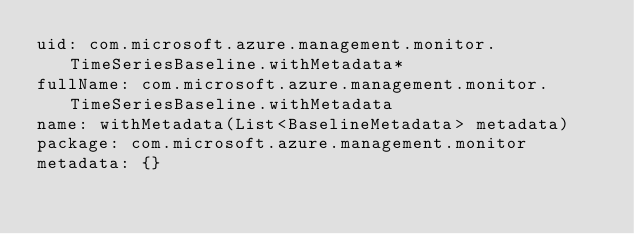<code> <loc_0><loc_0><loc_500><loc_500><_YAML_>uid: com.microsoft.azure.management.monitor.TimeSeriesBaseline.withMetadata*
fullName: com.microsoft.azure.management.monitor.TimeSeriesBaseline.withMetadata
name: withMetadata(List<BaselineMetadata> metadata)
package: com.microsoft.azure.management.monitor
metadata: {}
</code> 